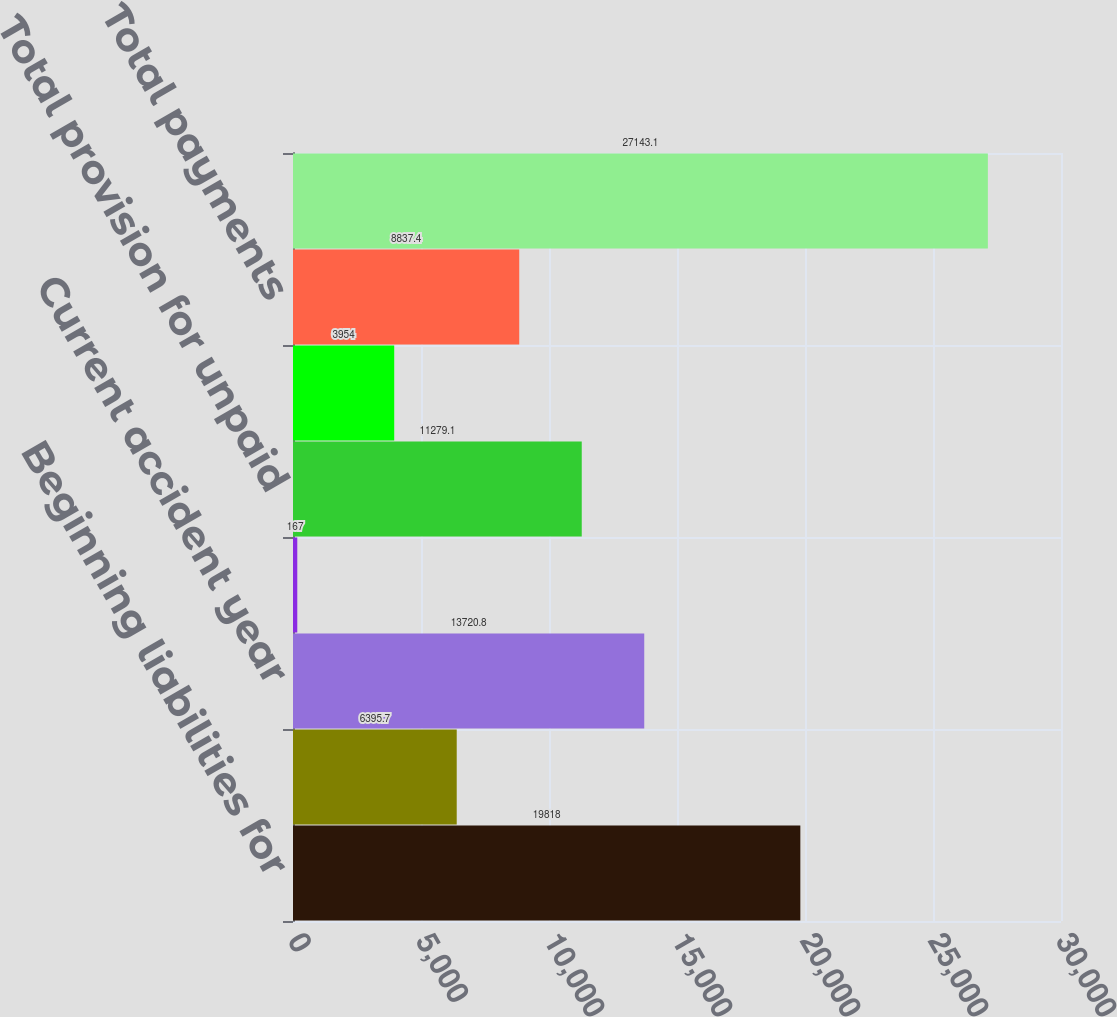<chart> <loc_0><loc_0><loc_500><loc_500><bar_chart><fcel>Beginning liabilities for<fcel>Reinsurance and other<fcel>Current accident year<fcel>Prior accident year<fcel>Total provision for unpaid<fcel>Prior accident years<fcel>Total payments<fcel>Ending liabilities for unpaid<nl><fcel>19818<fcel>6395.7<fcel>13720.8<fcel>167<fcel>11279.1<fcel>3954<fcel>8837.4<fcel>27143.1<nl></chart> 